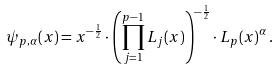<formula> <loc_0><loc_0><loc_500><loc_500>\psi _ { p , \alpha } ( x ) = x ^ { - \frac { 1 } { 2 } } \cdot \left ( \prod _ { j = 1 } ^ { p - 1 } L _ { j } ( x ) \right ) ^ { - \frac { 1 } { 2 } } \cdot L _ { p } ( x ) ^ { \alpha } \, .</formula> 